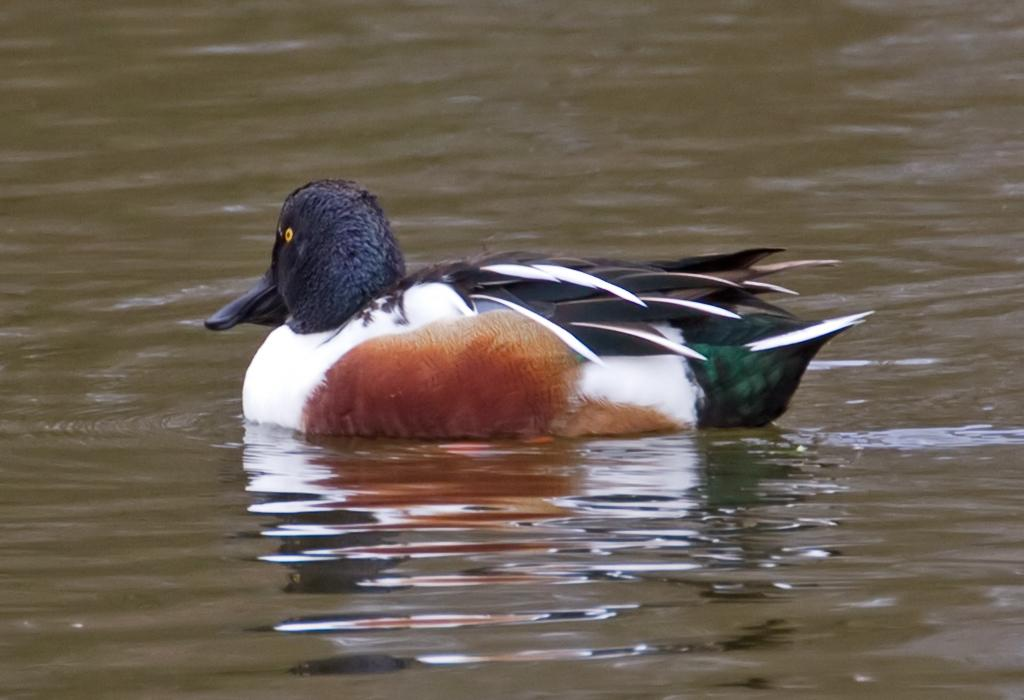What animal can be seen in the image? There is a duck in the image. What is the duck doing in the image? The duck is swimming in the river. How many snakes are accompanying the duck on its journey in the image? There are no snakes present in the image, and the duck is not depicted as being on a journey. 